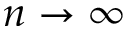Convert formula to latex. <formula><loc_0><loc_0><loc_500><loc_500>n \rightarrow \infty</formula> 